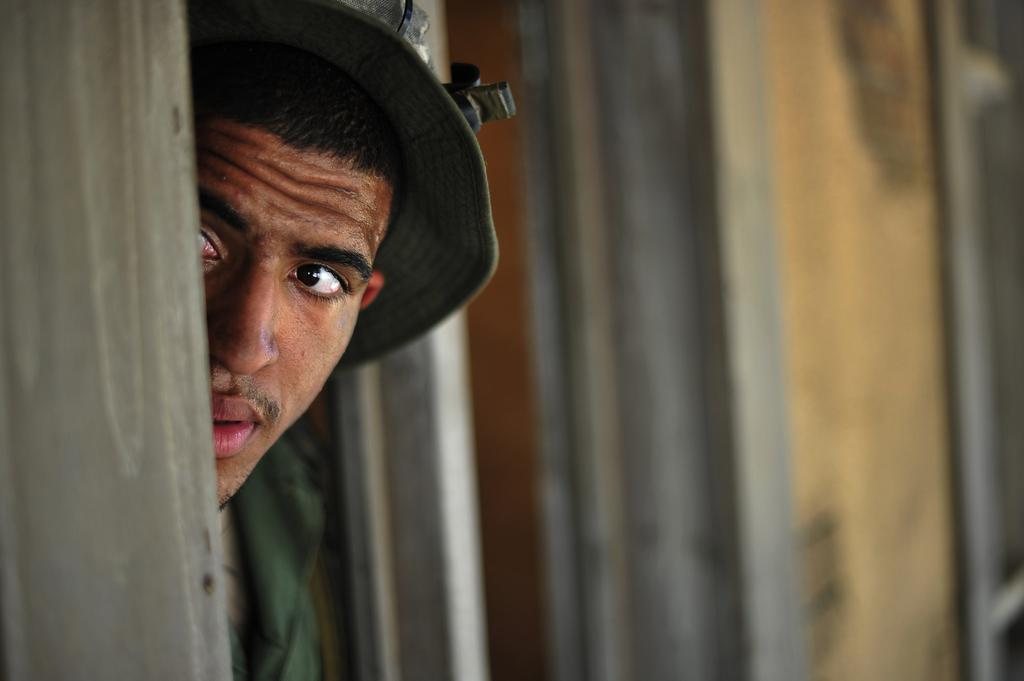Who is present in the image? There is a man in the image. Where is the man located in the image? The man is on the left side of the image. What is the man doing or standing behind in the image? The man is behind a wooden plank. What is the man wearing on his head? The man is wearing a cap. What can be seen in the background of the image? There are wooden planks visible in the background of the image. What type of birds can be seen flying in the image? There are no birds visible in the image; it features a man behind a wooden plank. What day of the week is it in the image? The image does not provide information about the day of the week. 